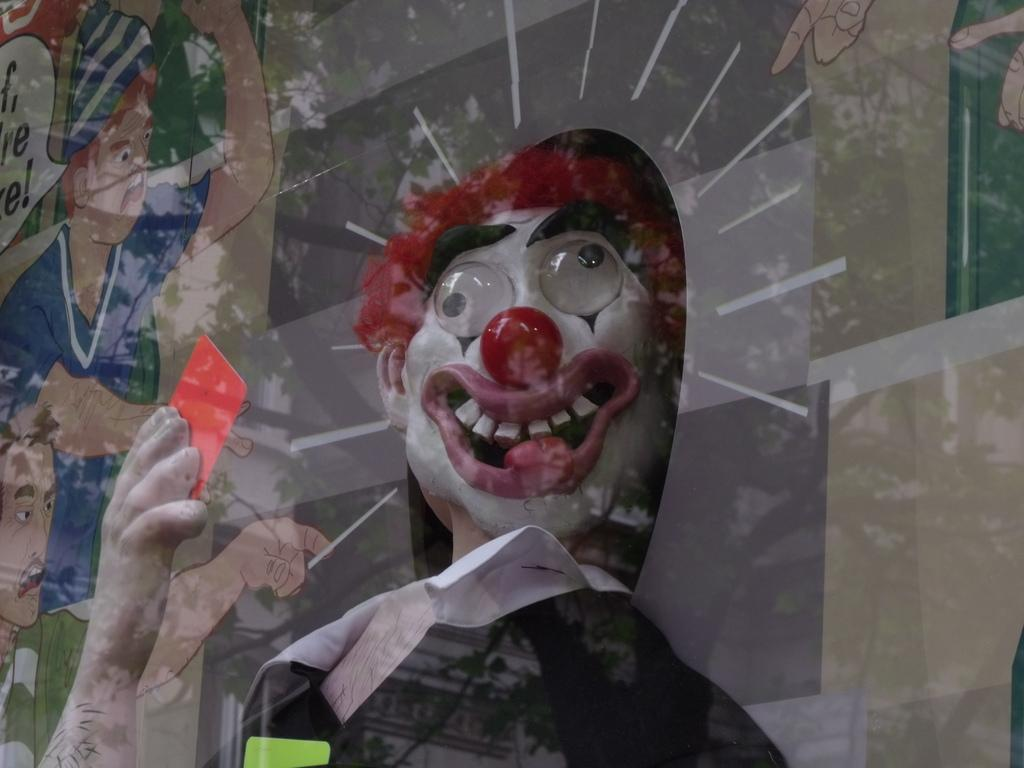What object is present in the picture that can hold a liquid? There is a glass in the picture. What can be seen on the surface of the glass? There is a reflection on the glass. What type of images are present in the picture? There are pictures of animated people in the image. Can you describe a specific character in the image? There is a joker in the image. What type of oil is being traded in the image? There is no mention of oil or trade in the image, as it features a glass with a reflection and pictures of animated people, including a joker. 